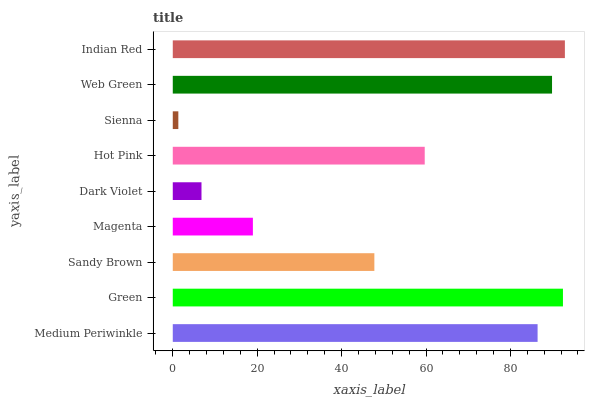Is Sienna the minimum?
Answer yes or no. Yes. Is Indian Red the maximum?
Answer yes or no. Yes. Is Green the minimum?
Answer yes or no. No. Is Green the maximum?
Answer yes or no. No. Is Green greater than Medium Periwinkle?
Answer yes or no. Yes. Is Medium Periwinkle less than Green?
Answer yes or no. Yes. Is Medium Periwinkle greater than Green?
Answer yes or no. No. Is Green less than Medium Periwinkle?
Answer yes or no. No. Is Hot Pink the high median?
Answer yes or no. Yes. Is Hot Pink the low median?
Answer yes or no. Yes. Is Dark Violet the high median?
Answer yes or no. No. Is Medium Periwinkle the low median?
Answer yes or no. No. 